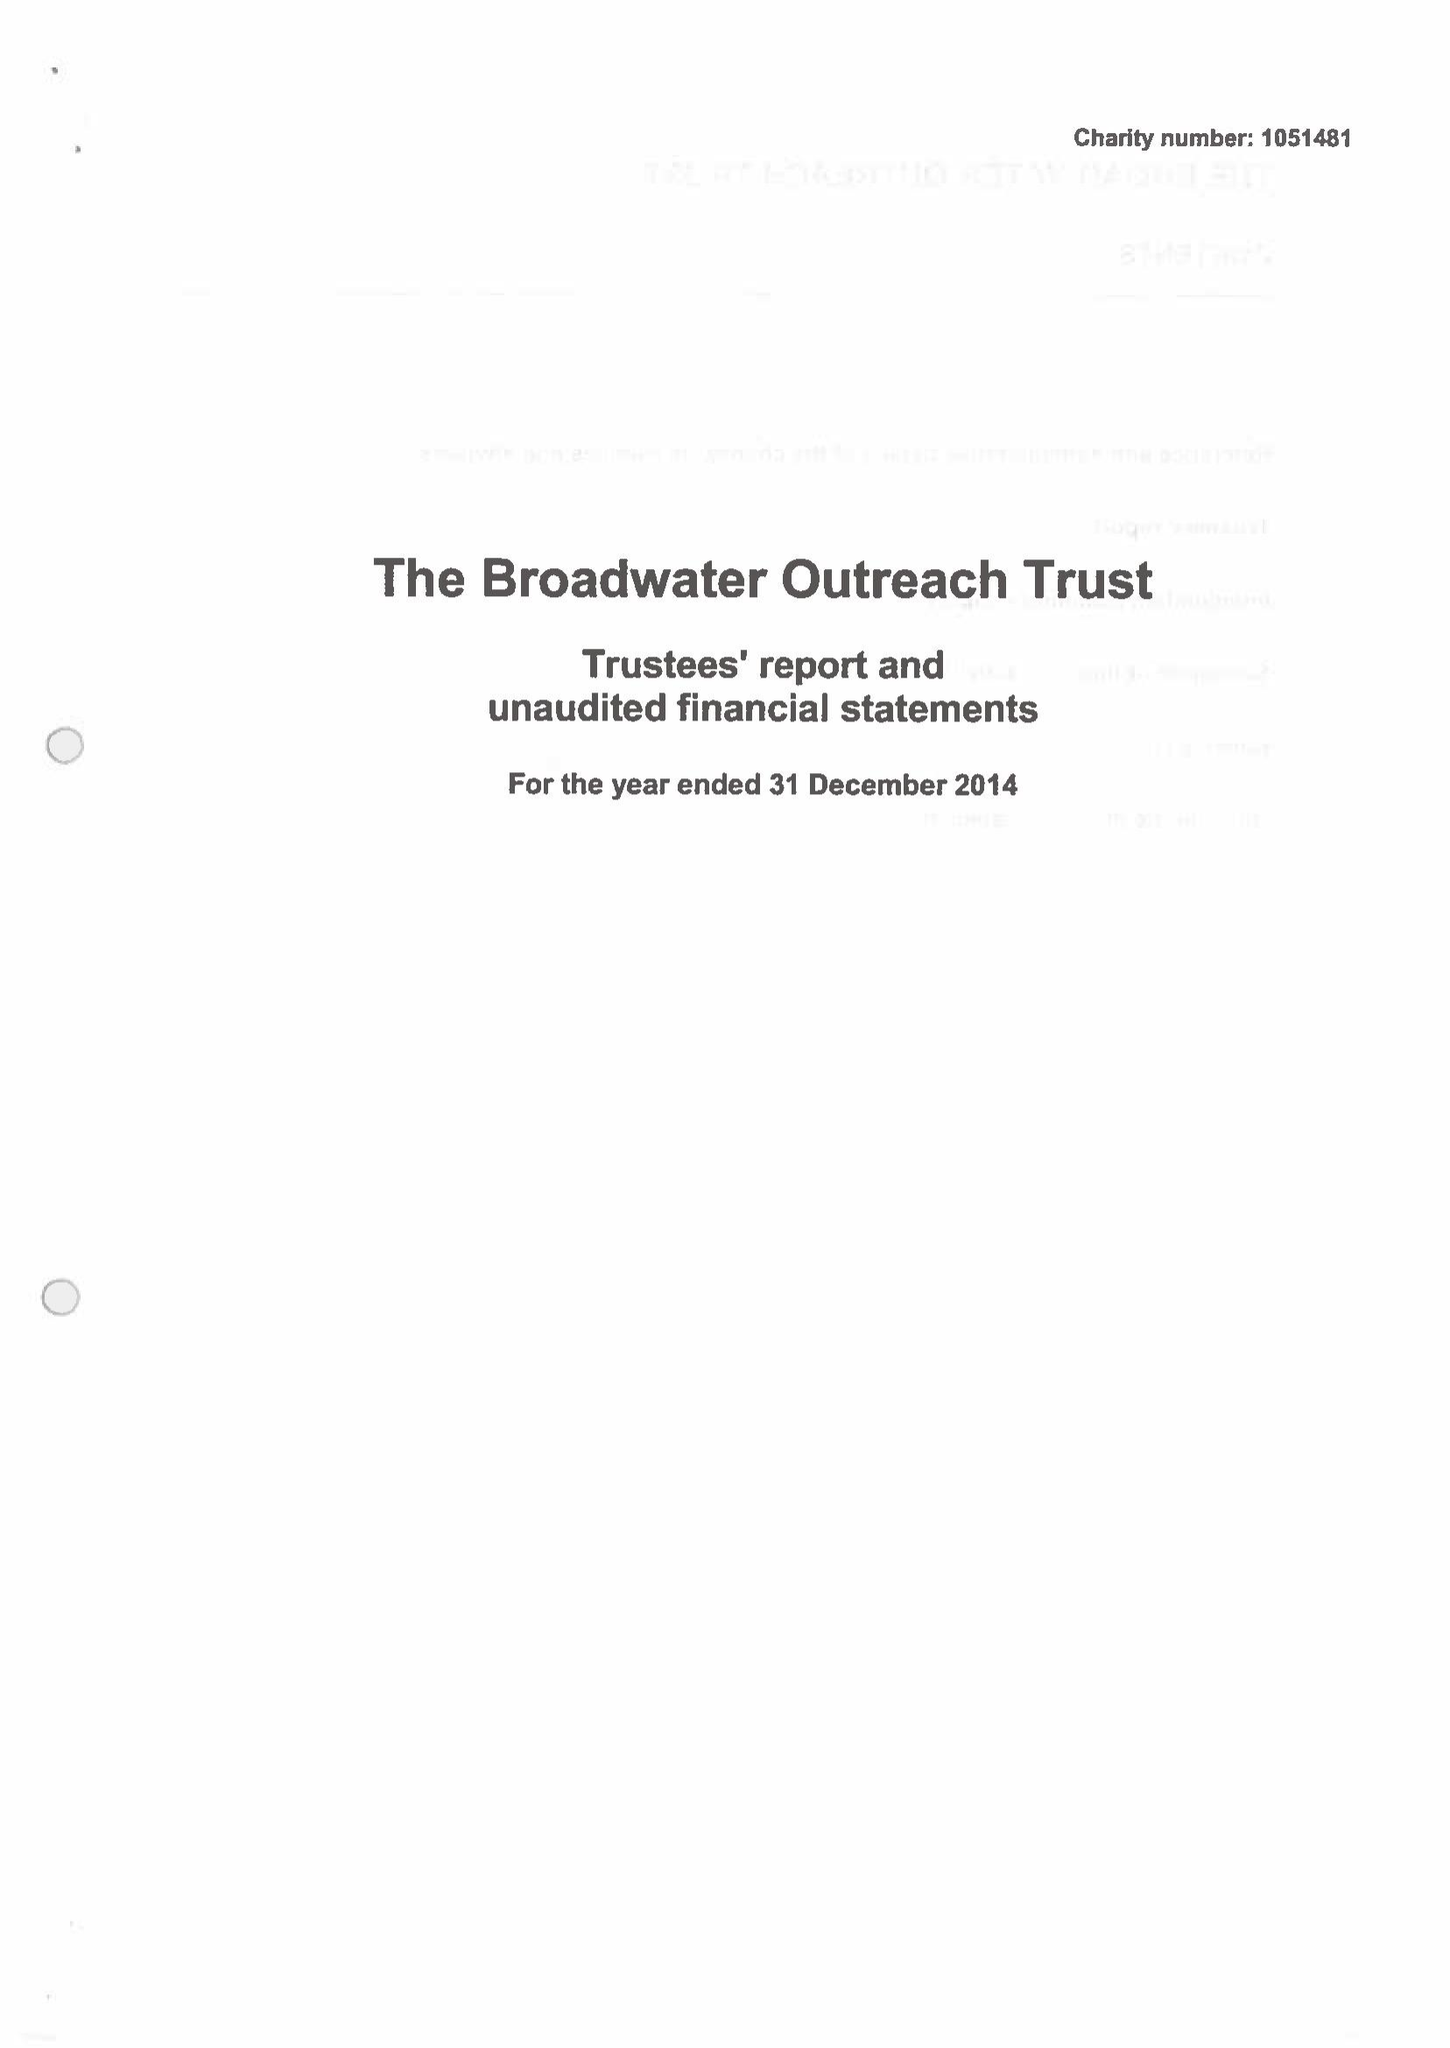What is the value for the income_annually_in_british_pounds?
Answer the question using a single word or phrase. 26809.00 